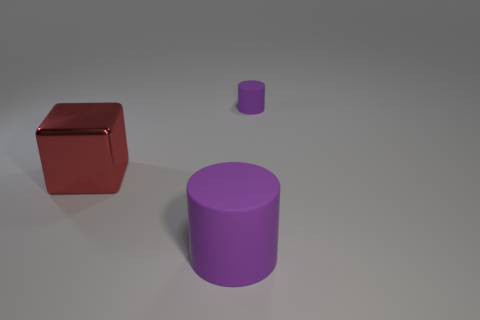There is another purple object that is the same shape as the small purple rubber thing; what is its size?
Provide a succinct answer. Large. The other thing that is the same size as the red metal object is what shape?
Keep it short and to the point. Cylinder. What number of things are purple cylinders that are in front of the large red metal thing or purple cylinders to the left of the small rubber cylinder?
Keep it short and to the point. 1. How many other objects are the same material as the large red cube?
Offer a terse response. 0. Is the number of big red metal blocks in front of the big cube the same as the number of purple objects that are behind the large cylinder?
Your response must be concise. No. How many purple things are either matte things or large cubes?
Offer a very short reply. 2. Do the small matte thing and the object in front of the large red cube have the same color?
Make the answer very short. Yes. What number of other objects are there of the same color as the metallic thing?
Your answer should be very brief. 0. Are there fewer tiny rubber things than tiny spheres?
Keep it short and to the point. No. There is a purple cylinder in front of the thing behind the red cube; how many matte things are behind it?
Keep it short and to the point. 1. 